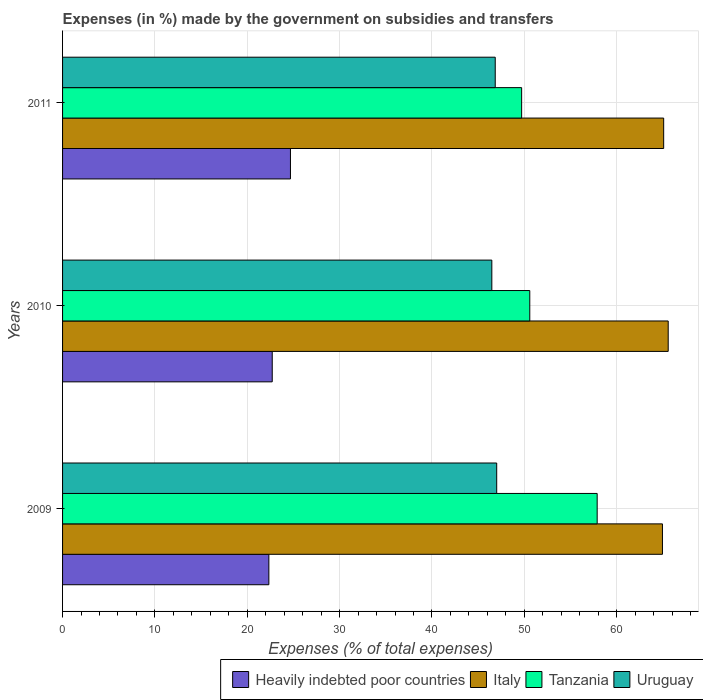How many different coloured bars are there?
Offer a very short reply. 4. How many groups of bars are there?
Make the answer very short. 3. How many bars are there on the 3rd tick from the top?
Your response must be concise. 4. How many bars are there on the 1st tick from the bottom?
Your response must be concise. 4. What is the label of the 2nd group of bars from the top?
Offer a terse response. 2010. In how many cases, is the number of bars for a given year not equal to the number of legend labels?
Your answer should be compact. 0. What is the percentage of expenses made by the government on subsidies and transfers in Tanzania in 2011?
Your answer should be very brief. 49.71. Across all years, what is the maximum percentage of expenses made by the government on subsidies and transfers in Tanzania?
Make the answer very short. 57.89. Across all years, what is the minimum percentage of expenses made by the government on subsidies and transfers in Uruguay?
Provide a short and direct response. 46.48. In which year was the percentage of expenses made by the government on subsidies and transfers in Heavily indebted poor countries maximum?
Your response must be concise. 2011. In which year was the percentage of expenses made by the government on subsidies and transfers in Italy minimum?
Offer a very short reply. 2009. What is the total percentage of expenses made by the government on subsidies and transfers in Heavily indebted poor countries in the graph?
Make the answer very short. 69.72. What is the difference between the percentage of expenses made by the government on subsidies and transfers in Uruguay in 2009 and that in 2010?
Provide a succinct answer. 0.53. What is the difference between the percentage of expenses made by the government on subsidies and transfers in Italy in 2010 and the percentage of expenses made by the government on subsidies and transfers in Uruguay in 2009?
Your answer should be compact. 18.57. What is the average percentage of expenses made by the government on subsidies and transfers in Italy per year?
Make the answer very short. 65.21. In the year 2010, what is the difference between the percentage of expenses made by the government on subsidies and transfers in Tanzania and percentage of expenses made by the government on subsidies and transfers in Italy?
Keep it short and to the point. -14.99. In how many years, is the percentage of expenses made by the government on subsidies and transfers in Uruguay greater than 24 %?
Your answer should be very brief. 3. What is the ratio of the percentage of expenses made by the government on subsidies and transfers in Tanzania in 2009 to that in 2010?
Your answer should be compact. 1.14. What is the difference between the highest and the second highest percentage of expenses made by the government on subsidies and transfers in Tanzania?
Provide a short and direct response. 7.3. What is the difference between the highest and the lowest percentage of expenses made by the government on subsidies and transfers in Tanzania?
Your answer should be very brief. 8.18. Is the sum of the percentage of expenses made by the government on subsidies and transfers in Heavily indebted poor countries in 2010 and 2011 greater than the maximum percentage of expenses made by the government on subsidies and transfers in Uruguay across all years?
Keep it short and to the point. Yes. What does the 2nd bar from the top in 2010 represents?
Keep it short and to the point. Tanzania. What does the 4th bar from the bottom in 2010 represents?
Make the answer very short. Uruguay. Is it the case that in every year, the sum of the percentage of expenses made by the government on subsidies and transfers in Uruguay and percentage of expenses made by the government on subsidies and transfers in Tanzania is greater than the percentage of expenses made by the government on subsidies and transfers in Heavily indebted poor countries?
Your answer should be compact. Yes. Are the values on the major ticks of X-axis written in scientific E-notation?
Make the answer very short. No. Does the graph contain any zero values?
Provide a succinct answer. No. How are the legend labels stacked?
Offer a terse response. Horizontal. What is the title of the graph?
Offer a terse response. Expenses (in %) made by the government on subsidies and transfers. What is the label or title of the X-axis?
Your response must be concise. Expenses (% of total expenses). What is the Expenses (% of total expenses) of Heavily indebted poor countries in 2009?
Offer a very short reply. 22.34. What is the Expenses (% of total expenses) in Italy in 2009?
Your answer should be compact. 64.96. What is the Expenses (% of total expenses) in Tanzania in 2009?
Offer a very short reply. 57.89. What is the Expenses (% of total expenses) in Uruguay in 2009?
Make the answer very short. 47.01. What is the Expenses (% of total expenses) of Heavily indebted poor countries in 2010?
Your answer should be compact. 22.7. What is the Expenses (% of total expenses) of Italy in 2010?
Offer a very short reply. 65.58. What is the Expenses (% of total expenses) of Tanzania in 2010?
Offer a terse response. 50.59. What is the Expenses (% of total expenses) in Uruguay in 2010?
Offer a very short reply. 46.48. What is the Expenses (% of total expenses) of Heavily indebted poor countries in 2011?
Your response must be concise. 24.68. What is the Expenses (% of total expenses) of Italy in 2011?
Provide a succinct answer. 65.09. What is the Expenses (% of total expenses) in Tanzania in 2011?
Your answer should be compact. 49.71. What is the Expenses (% of total expenses) of Uruguay in 2011?
Your answer should be compact. 46.85. Across all years, what is the maximum Expenses (% of total expenses) of Heavily indebted poor countries?
Provide a succinct answer. 24.68. Across all years, what is the maximum Expenses (% of total expenses) of Italy?
Your response must be concise. 65.58. Across all years, what is the maximum Expenses (% of total expenses) of Tanzania?
Your answer should be very brief. 57.89. Across all years, what is the maximum Expenses (% of total expenses) of Uruguay?
Ensure brevity in your answer.  47.01. Across all years, what is the minimum Expenses (% of total expenses) of Heavily indebted poor countries?
Offer a terse response. 22.34. Across all years, what is the minimum Expenses (% of total expenses) of Italy?
Your answer should be very brief. 64.96. Across all years, what is the minimum Expenses (% of total expenses) in Tanzania?
Provide a succinct answer. 49.71. Across all years, what is the minimum Expenses (% of total expenses) in Uruguay?
Your answer should be very brief. 46.48. What is the total Expenses (% of total expenses) of Heavily indebted poor countries in the graph?
Your response must be concise. 69.72. What is the total Expenses (% of total expenses) in Italy in the graph?
Offer a terse response. 195.63. What is the total Expenses (% of total expenses) of Tanzania in the graph?
Keep it short and to the point. 158.19. What is the total Expenses (% of total expenses) of Uruguay in the graph?
Keep it short and to the point. 140.34. What is the difference between the Expenses (% of total expenses) in Heavily indebted poor countries in 2009 and that in 2010?
Offer a very short reply. -0.37. What is the difference between the Expenses (% of total expenses) of Italy in 2009 and that in 2010?
Ensure brevity in your answer.  -0.62. What is the difference between the Expenses (% of total expenses) in Tanzania in 2009 and that in 2010?
Your response must be concise. 7.3. What is the difference between the Expenses (% of total expenses) of Uruguay in 2009 and that in 2010?
Offer a terse response. 0.53. What is the difference between the Expenses (% of total expenses) in Heavily indebted poor countries in 2009 and that in 2011?
Offer a very short reply. -2.34. What is the difference between the Expenses (% of total expenses) of Italy in 2009 and that in 2011?
Make the answer very short. -0.13. What is the difference between the Expenses (% of total expenses) in Tanzania in 2009 and that in 2011?
Offer a very short reply. 8.18. What is the difference between the Expenses (% of total expenses) in Uruguay in 2009 and that in 2011?
Make the answer very short. 0.16. What is the difference between the Expenses (% of total expenses) of Heavily indebted poor countries in 2010 and that in 2011?
Offer a very short reply. -1.97. What is the difference between the Expenses (% of total expenses) in Italy in 2010 and that in 2011?
Your answer should be compact. 0.49. What is the difference between the Expenses (% of total expenses) in Tanzania in 2010 and that in 2011?
Provide a short and direct response. 0.88. What is the difference between the Expenses (% of total expenses) in Uruguay in 2010 and that in 2011?
Offer a very short reply. -0.37. What is the difference between the Expenses (% of total expenses) of Heavily indebted poor countries in 2009 and the Expenses (% of total expenses) of Italy in 2010?
Your answer should be compact. -43.24. What is the difference between the Expenses (% of total expenses) of Heavily indebted poor countries in 2009 and the Expenses (% of total expenses) of Tanzania in 2010?
Keep it short and to the point. -28.25. What is the difference between the Expenses (% of total expenses) in Heavily indebted poor countries in 2009 and the Expenses (% of total expenses) in Uruguay in 2010?
Your answer should be compact. -24.14. What is the difference between the Expenses (% of total expenses) in Italy in 2009 and the Expenses (% of total expenses) in Tanzania in 2010?
Provide a short and direct response. 14.37. What is the difference between the Expenses (% of total expenses) in Italy in 2009 and the Expenses (% of total expenses) in Uruguay in 2010?
Your response must be concise. 18.48. What is the difference between the Expenses (% of total expenses) in Tanzania in 2009 and the Expenses (% of total expenses) in Uruguay in 2010?
Give a very brief answer. 11.41. What is the difference between the Expenses (% of total expenses) in Heavily indebted poor countries in 2009 and the Expenses (% of total expenses) in Italy in 2011?
Make the answer very short. -42.75. What is the difference between the Expenses (% of total expenses) in Heavily indebted poor countries in 2009 and the Expenses (% of total expenses) in Tanzania in 2011?
Make the answer very short. -27.37. What is the difference between the Expenses (% of total expenses) in Heavily indebted poor countries in 2009 and the Expenses (% of total expenses) in Uruguay in 2011?
Ensure brevity in your answer.  -24.51. What is the difference between the Expenses (% of total expenses) in Italy in 2009 and the Expenses (% of total expenses) in Tanzania in 2011?
Provide a short and direct response. 15.25. What is the difference between the Expenses (% of total expenses) in Italy in 2009 and the Expenses (% of total expenses) in Uruguay in 2011?
Make the answer very short. 18.11. What is the difference between the Expenses (% of total expenses) in Tanzania in 2009 and the Expenses (% of total expenses) in Uruguay in 2011?
Give a very brief answer. 11.04. What is the difference between the Expenses (% of total expenses) of Heavily indebted poor countries in 2010 and the Expenses (% of total expenses) of Italy in 2011?
Offer a terse response. -42.39. What is the difference between the Expenses (% of total expenses) in Heavily indebted poor countries in 2010 and the Expenses (% of total expenses) in Tanzania in 2011?
Give a very brief answer. -27.01. What is the difference between the Expenses (% of total expenses) in Heavily indebted poor countries in 2010 and the Expenses (% of total expenses) in Uruguay in 2011?
Offer a terse response. -24.15. What is the difference between the Expenses (% of total expenses) in Italy in 2010 and the Expenses (% of total expenses) in Tanzania in 2011?
Your response must be concise. 15.87. What is the difference between the Expenses (% of total expenses) of Italy in 2010 and the Expenses (% of total expenses) of Uruguay in 2011?
Offer a terse response. 18.73. What is the difference between the Expenses (% of total expenses) in Tanzania in 2010 and the Expenses (% of total expenses) in Uruguay in 2011?
Provide a short and direct response. 3.74. What is the average Expenses (% of total expenses) of Heavily indebted poor countries per year?
Provide a short and direct response. 23.24. What is the average Expenses (% of total expenses) in Italy per year?
Make the answer very short. 65.21. What is the average Expenses (% of total expenses) of Tanzania per year?
Make the answer very short. 52.73. What is the average Expenses (% of total expenses) in Uruguay per year?
Keep it short and to the point. 46.78. In the year 2009, what is the difference between the Expenses (% of total expenses) in Heavily indebted poor countries and Expenses (% of total expenses) in Italy?
Your answer should be compact. -42.62. In the year 2009, what is the difference between the Expenses (% of total expenses) of Heavily indebted poor countries and Expenses (% of total expenses) of Tanzania?
Keep it short and to the point. -35.55. In the year 2009, what is the difference between the Expenses (% of total expenses) in Heavily indebted poor countries and Expenses (% of total expenses) in Uruguay?
Make the answer very short. -24.67. In the year 2009, what is the difference between the Expenses (% of total expenses) of Italy and Expenses (% of total expenses) of Tanzania?
Provide a succinct answer. 7.07. In the year 2009, what is the difference between the Expenses (% of total expenses) in Italy and Expenses (% of total expenses) in Uruguay?
Provide a short and direct response. 17.95. In the year 2009, what is the difference between the Expenses (% of total expenses) of Tanzania and Expenses (% of total expenses) of Uruguay?
Your answer should be very brief. 10.88. In the year 2010, what is the difference between the Expenses (% of total expenses) in Heavily indebted poor countries and Expenses (% of total expenses) in Italy?
Offer a very short reply. -42.88. In the year 2010, what is the difference between the Expenses (% of total expenses) in Heavily indebted poor countries and Expenses (% of total expenses) in Tanzania?
Your answer should be compact. -27.89. In the year 2010, what is the difference between the Expenses (% of total expenses) of Heavily indebted poor countries and Expenses (% of total expenses) of Uruguay?
Provide a succinct answer. -23.78. In the year 2010, what is the difference between the Expenses (% of total expenses) of Italy and Expenses (% of total expenses) of Tanzania?
Offer a very short reply. 14.99. In the year 2010, what is the difference between the Expenses (% of total expenses) of Italy and Expenses (% of total expenses) of Uruguay?
Offer a terse response. 19.1. In the year 2010, what is the difference between the Expenses (% of total expenses) in Tanzania and Expenses (% of total expenses) in Uruguay?
Offer a terse response. 4.11. In the year 2011, what is the difference between the Expenses (% of total expenses) of Heavily indebted poor countries and Expenses (% of total expenses) of Italy?
Your answer should be compact. -40.41. In the year 2011, what is the difference between the Expenses (% of total expenses) in Heavily indebted poor countries and Expenses (% of total expenses) in Tanzania?
Ensure brevity in your answer.  -25.03. In the year 2011, what is the difference between the Expenses (% of total expenses) of Heavily indebted poor countries and Expenses (% of total expenses) of Uruguay?
Your response must be concise. -22.18. In the year 2011, what is the difference between the Expenses (% of total expenses) in Italy and Expenses (% of total expenses) in Tanzania?
Keep it short and to the point. 15.38. In the year 2011, what is the difference between the Expenses (% of total expenses) in Italy and Expenses (% of total expenses) in Uruguay?
Your answer should be very brief. 18.24. In the year 2011, what is the difference between the Expenses (% of total expenses) in Tanzania and Expenses (% of total expenses) in Uruguay?
Give a very brief answer. 2.86. What is the ratio of the Expenses (% of total expenses) in Heavily indebted poor countries in 2009 to that in 2010?
Provide a short and direct response. 0.98. What is the ratio of the Expenses (% of total expenses) of Italy in 2009 to that in 2010?
Give a very brief answer. 0.99. What is the ratio of the Expenses (% of total expenses) in Tanzania in 2009 to that in 2010?
Keep it short and to the point. 1.14. What is the ratio of the Expenses (% of total expenses) in Uruguay in 2009 to that in 2010?
Provide a succinct answer. 1.01. What is the ratio of the Expenses (% of total expenses) of Heavily indebted poor countries in 2009 to that in 2011?
Give a very brief answer. 0.91. What is the ratio of the Expenses (% of total expenses) of Italy in 2009 to that in 2011?
Offer a very short reply. 1. What is the ratio of the Expenses (% of total expenses) of Tanzania in 2009 to that in 2011?
Offer a very short reply. 1.16. What is the ratio of the Expenses (% of total expenses) in Uruguay in 2009 to that in 2011?
Ensure brevity in your answer.  1. What is the ratio of the Expenses (% of total expenses) in Heavily indebted poor countries in 2010 to that in 2011?
Keep it short and to the point. 0.92. What is the ratio of the Expenses (% of total expenses) of Italy in 2010 to that in 2011?
Your response must be concise. 1.01. What is the ratio of the Expenses (% of total expenses) in Tanzania in 2010 to that in 2011?
Offer a very short reply. 1.02. What is the difference between the highest and the second highest Expenses (% of total expenses) in Heavily indebted poor countries?
Make the answer very short. 1.97. What is the difference between the highest and the second highest Expenses (% of total expenses) in Italy?
Provide a succinct answer. 0.49. What is the difference between the highest and the second highest Expenses (% of total expenses) of Tanzania?
Keep it short and to the point. 7.3. What is the difference between the highest and the second highest Expenses (% of total expenses) of Uruguay?
Your answer should be compact. 0.16. What is the difference between the highest and the lowest Expenses (% of total expenses) of Heavily indebted poor countries?
Your answer should be very brief. 2.34. What is the difference between the highest and the lowest Expenses (% of total expenses) of Italy?
Keep it short and to the point. 0.62. What is the difference between the highest and the lowest Expenses (% of total expenses) of Tanzania?
Your answer should be very brief. 8.18. What is the difference between the highest and the lowest Expenses (% of total expenses) of Uruguay?
Your answer should be compact. 0.53. 